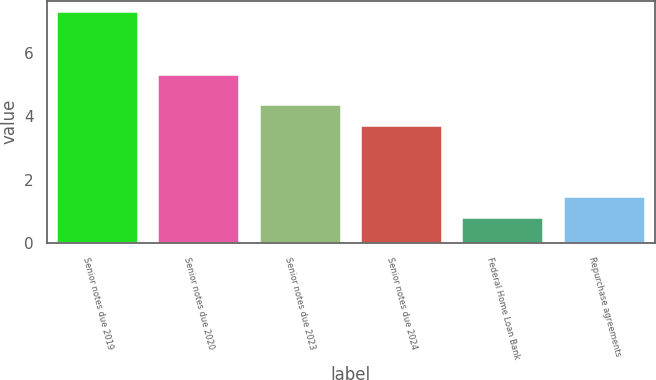Convert chart. <chart><loc_0><loc_0><loc_500><loc_500><bar_chart><fcel>Senior notes due 2019<fcel>Senior notes due 2020<fcel>Senior notes due 2023<fcel>Senior notes due 2024<fcel>Federal Home Loan Bank<fcel>Repurchase agreements<nl><fcel>7.3<fcel>5.3<fcel>4.35<fcel>3.7<fcel>0.8<fcel>1.45<nl></chart> 